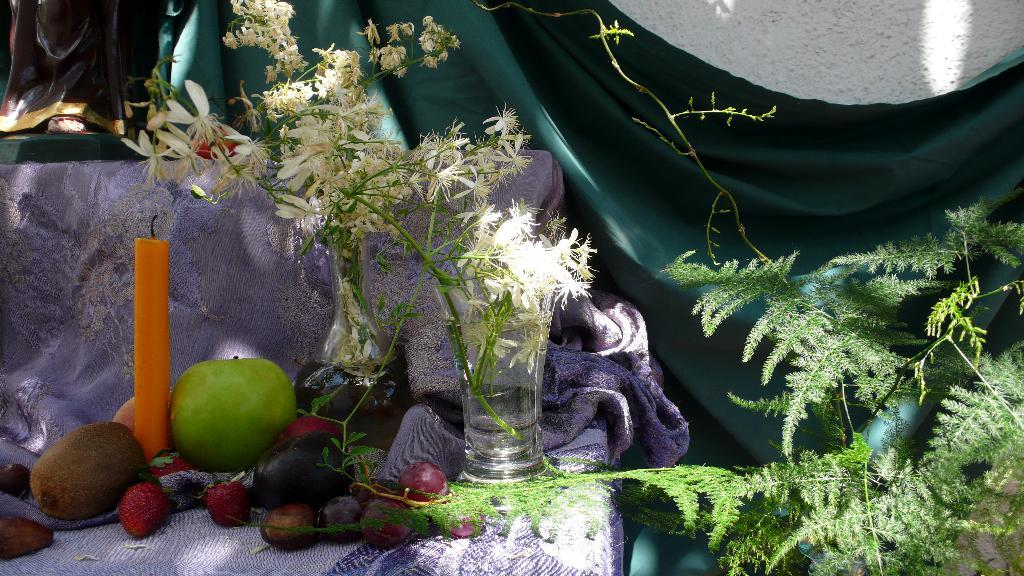What type of plant is visible in the image? There is a plant in the image, but its specific type cannot be determined from the provided facts. What color is the wall in the image? The wall in the image is white. What color is the cloth in the image? The cloth in the image is green. What type of furniture is present in the image? There is a sofa in the image. What type of food items are on the sofa? There are strawberries, a green apple, and white color flowers on the sofa. What other objects are on the sofa? There is a candle and a glass on the sofa. What type of dress is the person wearing in the image? There is no person or dress present in the image. On which side of the sofa are the strawberries placed? The provided facts do not specify the side of the sofa where the strawberries are placed. 